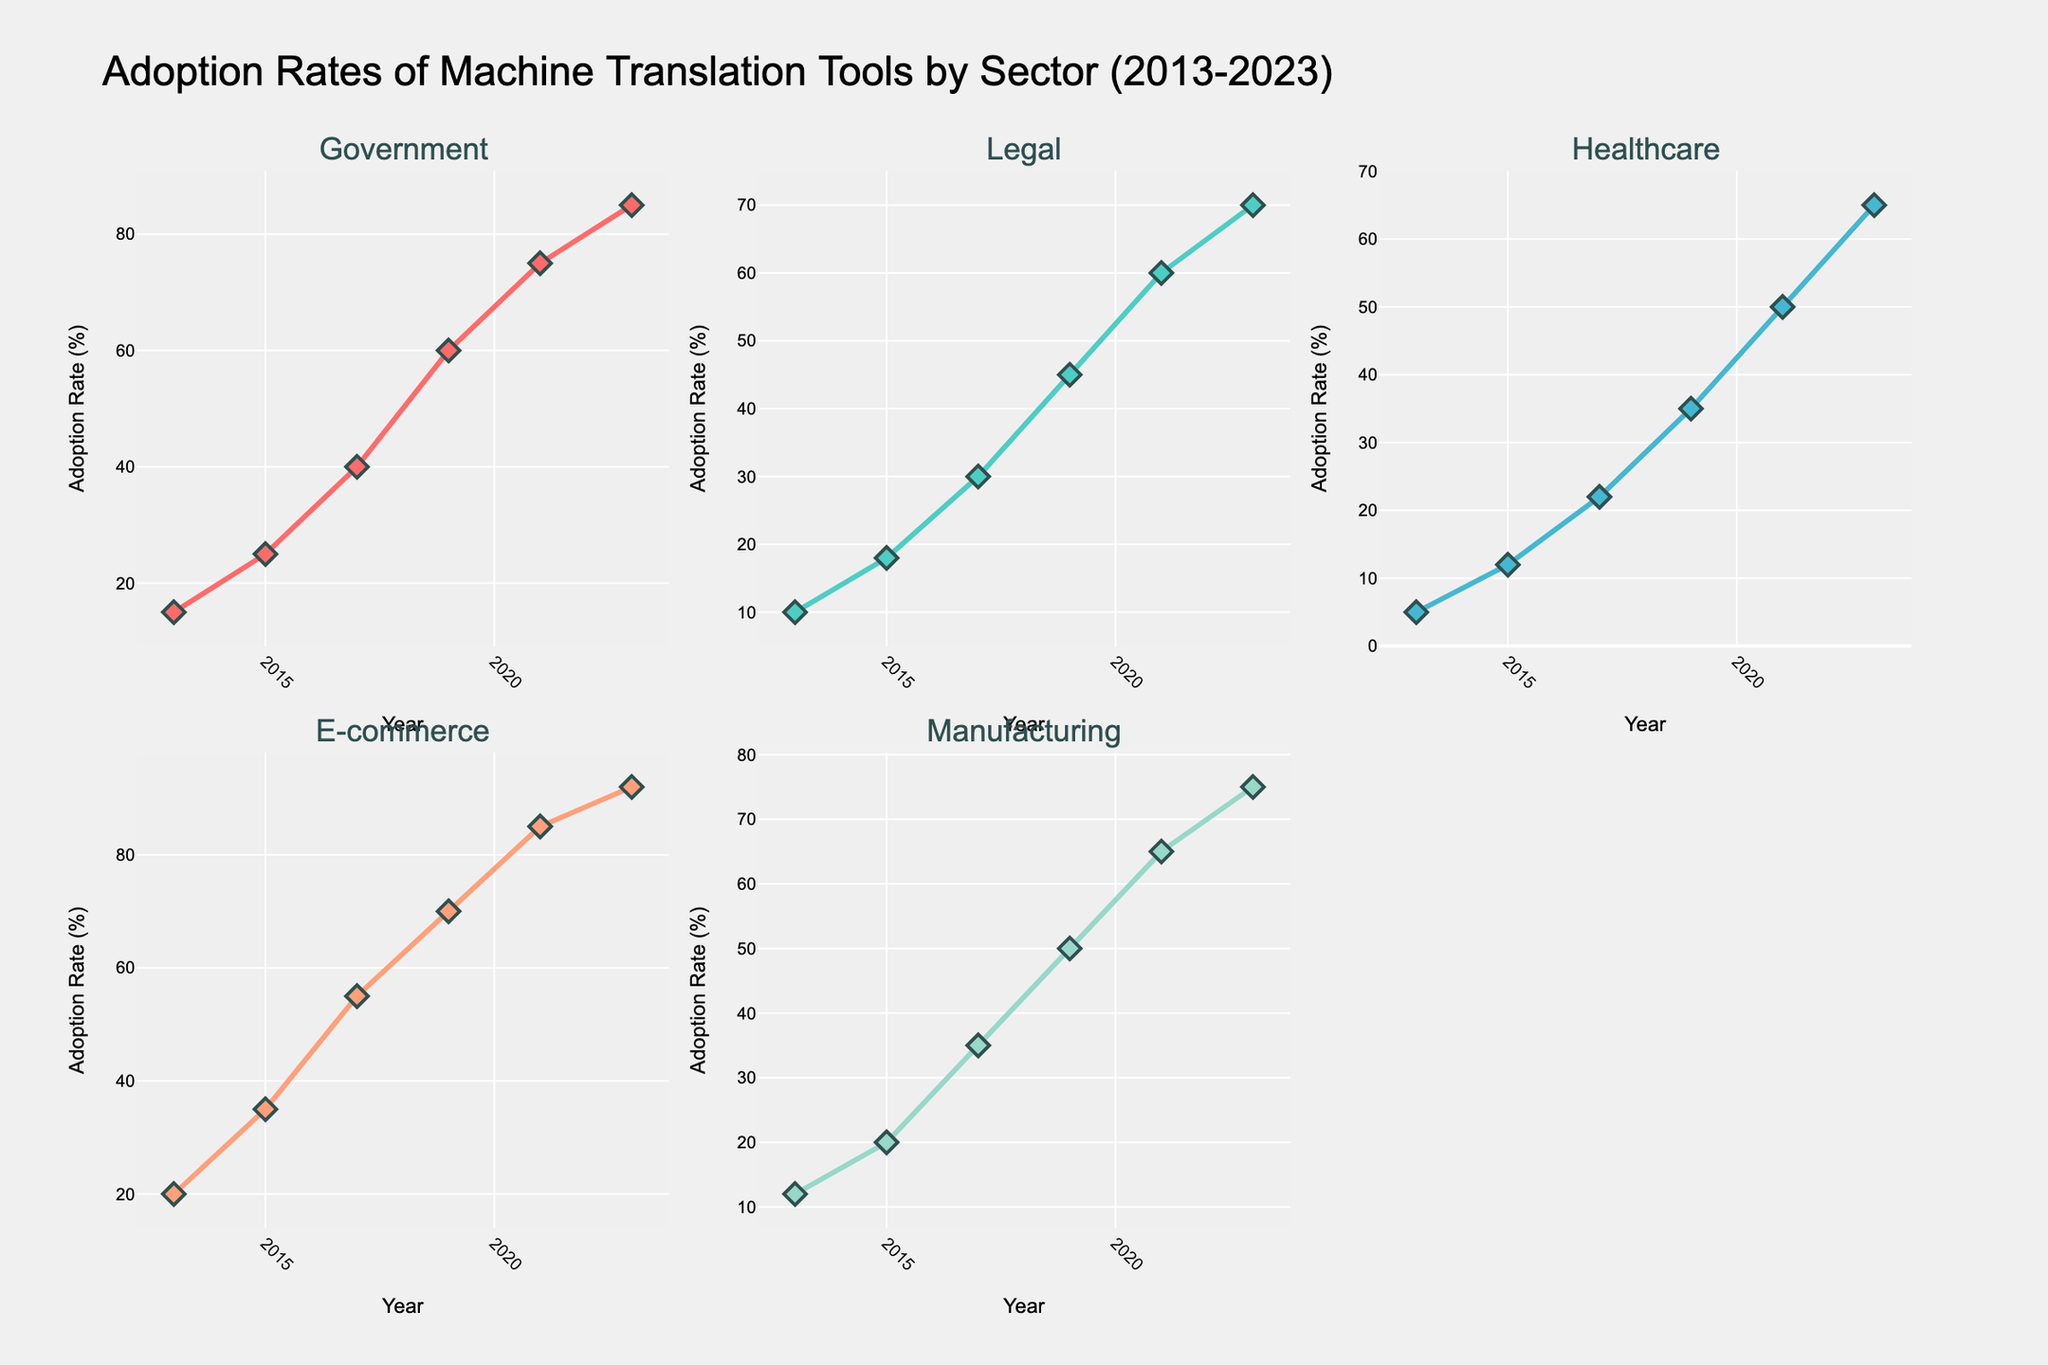What is the title of the figure? The title of the plot is located at the top and provides a clear description of what the figure is about. Referred to as the 'Adoption Rates of Machine Translation Tools by Sector (2013-2023)'.
Answer: Adoption Rates of Machine Translation Tools by Sector (2013-2023) What is the adoption rate of machine translation tools in the Government sector for the year 2013? Look at the "Government" subplot, then locate the point corresponding to the year 2013 on the x-axis and check the y-axis value for that point.
Answer: 15% Which sector had the highest adoption rate of machine translation tools in 2023? Compare the adoption rates for each sector in the year 2023 across all subplots. The sector with the highest y-axis value will have the highest adoption rate.
Answer: E-commerce Has the adoption rate in the Healthcare sector increased more between 2015 and 2023 compared to the Legal sector? Calculate the increase for both sectors: for Healthcare (65 - 12 = 53) and for Legal (70 - 18 = 52). Then compare the two values.
Answer: Yes Which year saw the largest increase in adoption rate in the Manufacturing sector? Look at the "Manufacturing" subplot and compare the adoption rate increases between successive years. Identify the year where the difference between consecutive points is the greatest.
Answer: 2017 What is the average adoption rate of machine translation tools in the E-commerce sector over the years provided? Sum the adoption rates for E-commerce (20 + 35 + 55 + 70 + 85 + 92 = 357) and divide by the number of years (6).
Answer: 59.5% Between which two years did the Government sector see the most substantial growth in adoption rates? In the "Government" subplot, find the differences between successive years and determine the largest increase: (2023-2021): 85-75=10, (2021-2019): 75-60=15, etc.
Answer: 2019 to 2021 What unique marker shape is used to represent the data points in the Legal sector subplot? Observe the markers used in the "Legal" subplot. The shape is consistently a specific geometric figure.
Answer: Diamond Is the adoption rate trend in the Manufacturing sector consistently increasing over the years? Examine the "Manufacturing" subplot and check if each subsequent point is higher than the previous one on the y-axis.
Answer: Yes In which sector is the increase between 2017 and 2019 the smallest? Calculate the increase for each sector during the period 2017 to 2019 and compare them: Government (60-40=20), Legal (45-30=15), etc. The sector with the smallest increase should be identified.
Answer: Legal 